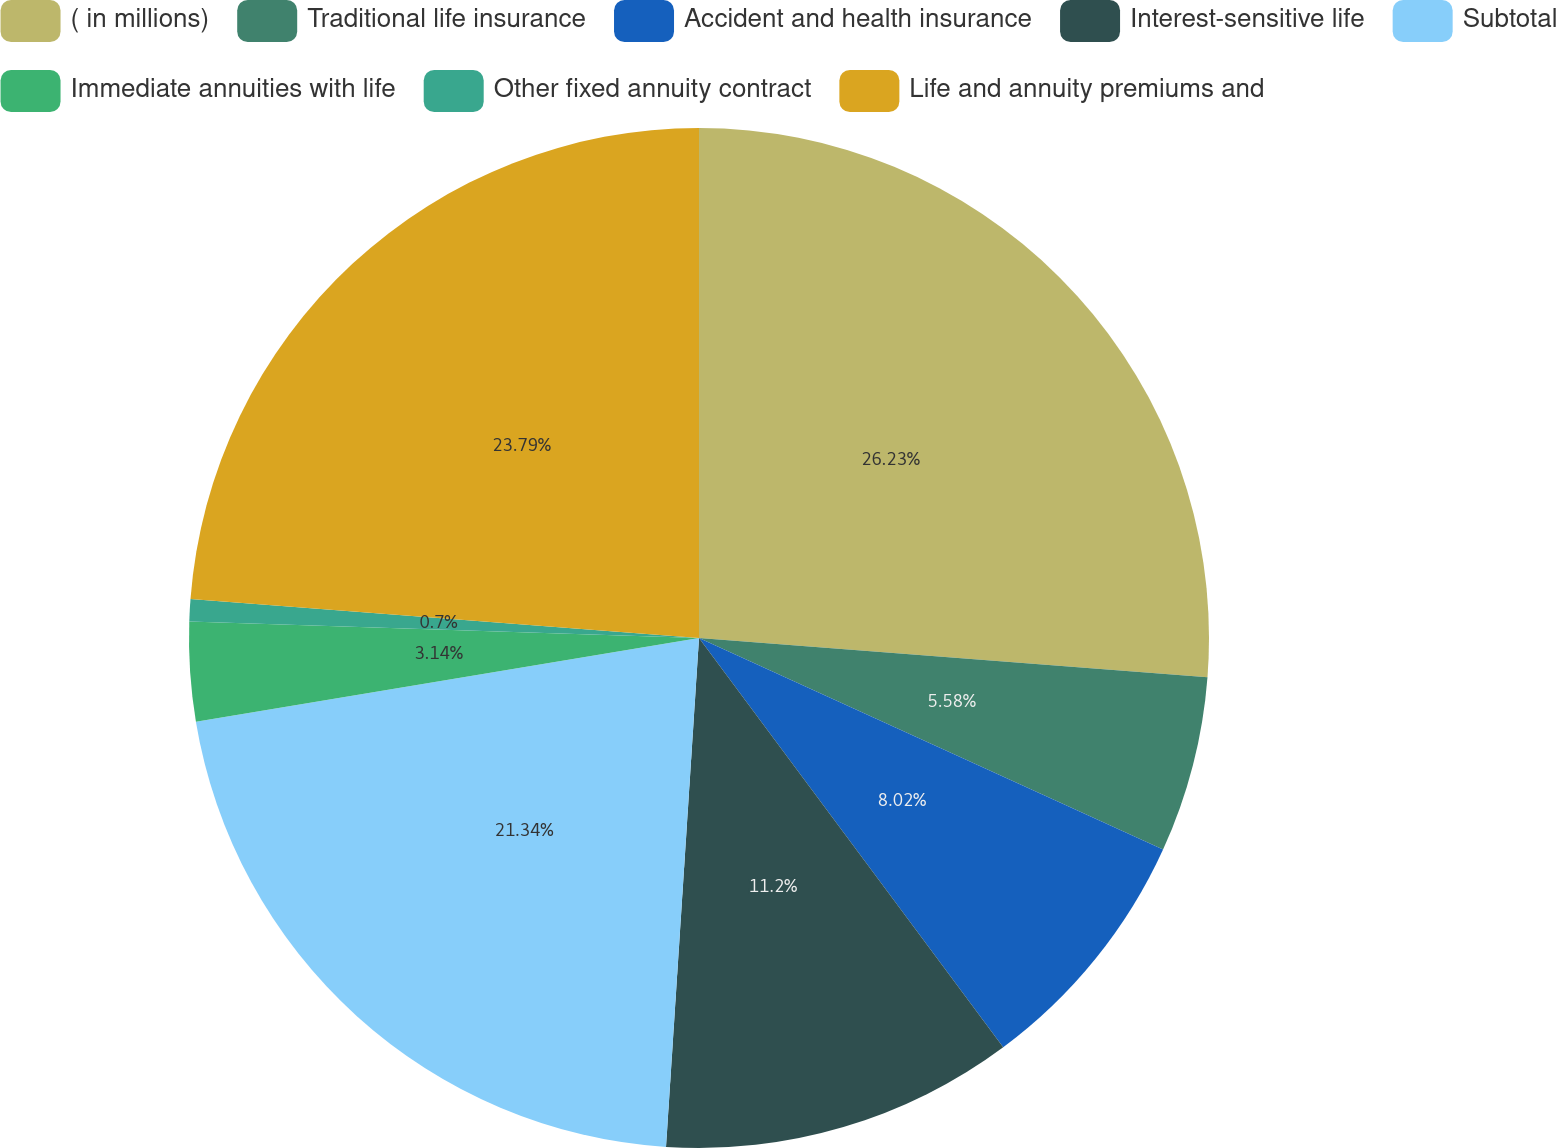Convert chart to OTSL. <chart><loc_0><loc_0><loc_500><loc_500><pie_chart><fcel>( in millions)<fcel>Traditional life insurance<fcel>Accident and health insurance<fcel>Interest-sensitive life<fcel>Subtotal<fcel>Immediate annuities with life<fcel>Other fixed annuity contract<fcel>Life and annuity premiums and<nl><fcel>26.22%<fcel>5.58%<fcel>8.02%<fcel>11.2%<fcel>21.34%<fcel>3.14%<fcel>0.7%<fcel>23.78%<nl></chart> 